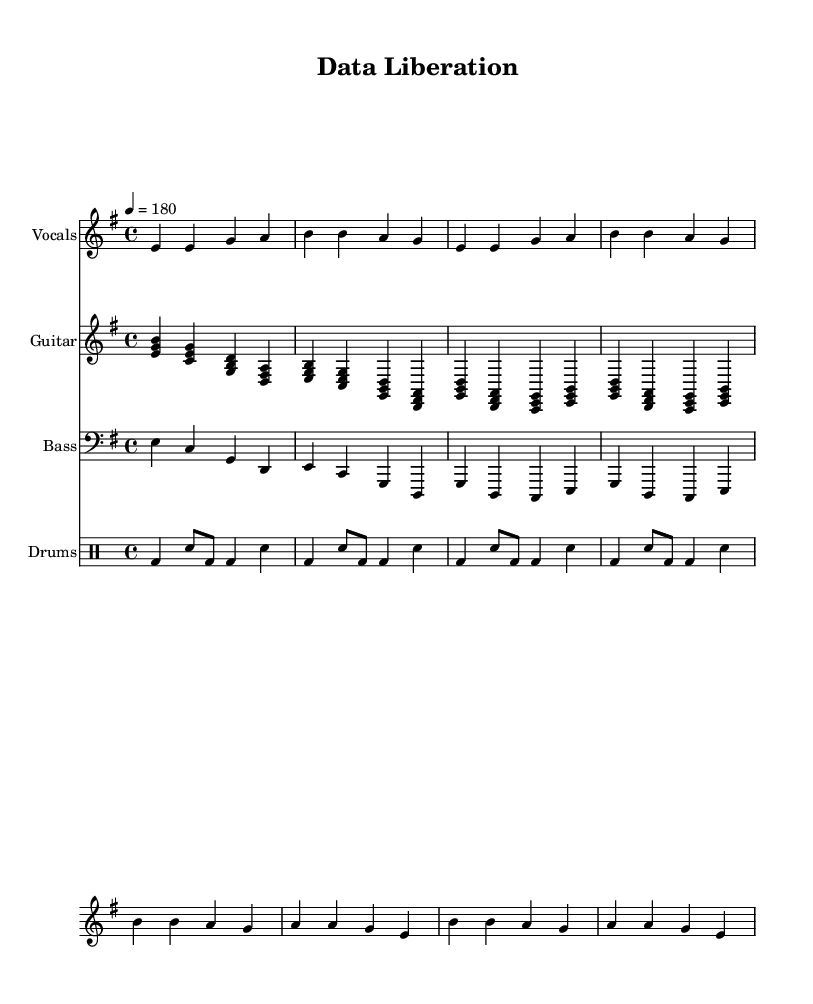What is the key signature of this music? The key signature is E minor, which has one sharp (F#).
Answer: E minor What is the time signature of this music? The time signature is 4/4, indicating four beats per measure.
Answer: 4/4 What is the tempo marking for the piece? The tempo marking is 180 beats per minute, suggesting a fast pace typical of punk music.
Answer: 180 How many measures are in the chorus section? The chorus section consists of four measures, which can be counted in the provided sheet music.
Answer: 4 What type of beat is used in the drum part? The drum part features a fast-paced punk beat, which is characterized by the use of bass and snare in an energetic rhythm.
Answer: Fast-paced punk beat Which instruments are included in this piece? The piece includes vocals, guitar, bass, and drums, as indicated by the separate staves for each instrument.
Answer: Vocals, guitar, bass, drums What is the chord progression pattern for the verse? The chord progression for the verse consists of four chords that repeat with the same structure throughout, specifically E minor, C major, G major, and D major.
Answer: E, C, G, D 